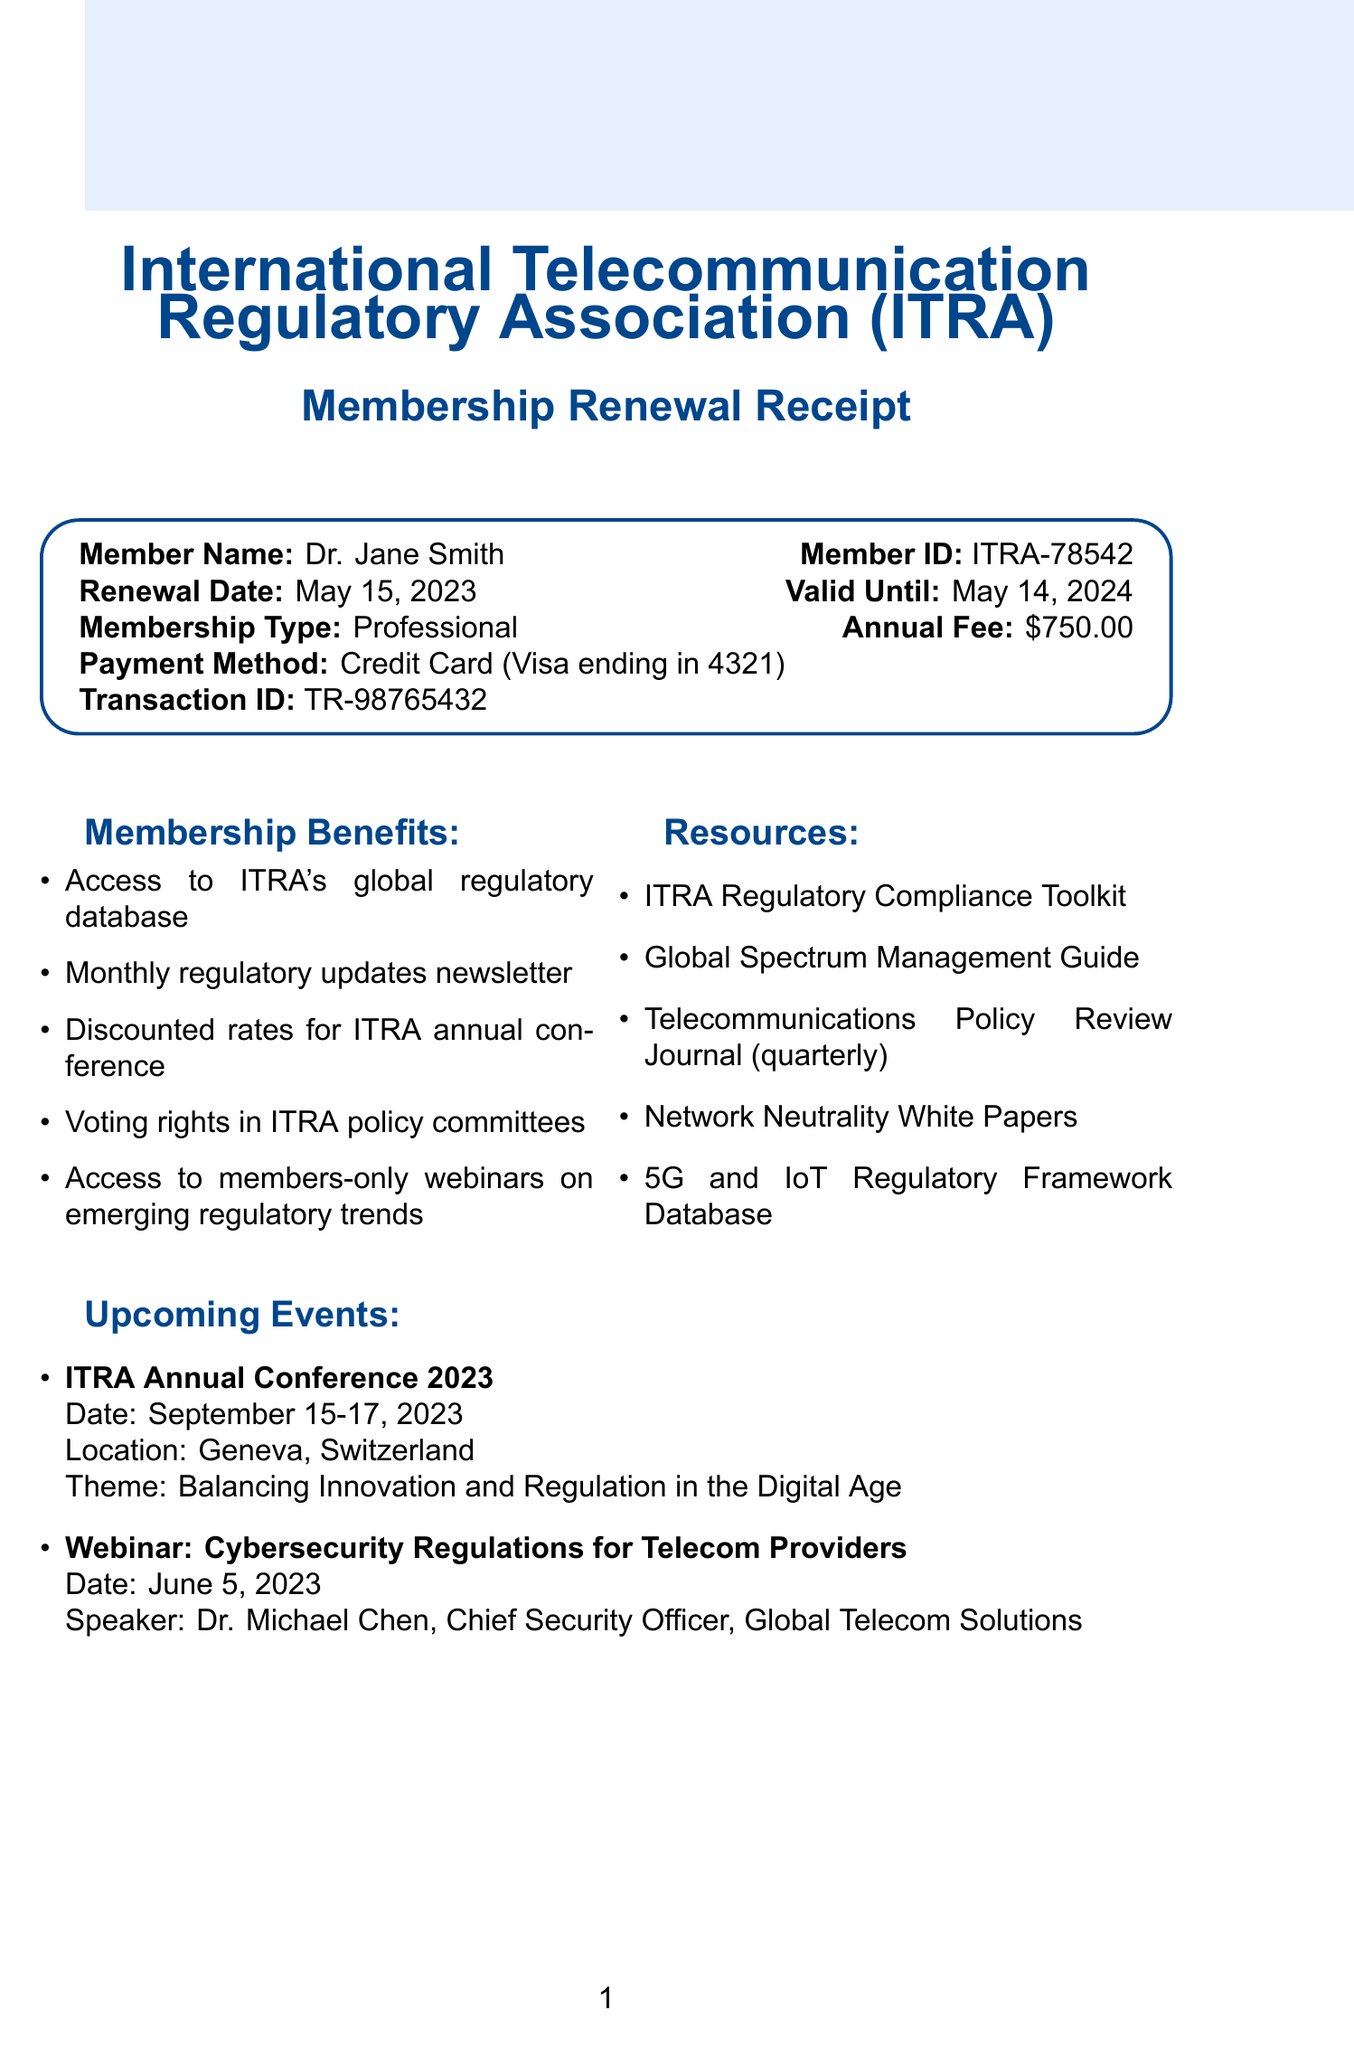What is the name of the association? The name of the association is explicitly stated in the document as the International Telecommunication Regulatory Association.
Answer: International Telecommunication Regulatory Association (ITRA) What is the member ID of Dr. Jane Smith? The member ID is a specific identifier for the individual, provided clearly in the receipt.
Answer: ITRA-78542 When does the membership expire? The document specifies the validity period of the membership, indicating the end date.
Answer: May 14, 2024 What is the annual fee for the professional membership? The annual fee for membership is listed directly in the document.
Answer: $750.00 What is one of the resources available to members? The document lists several resources available to members, indicating they can access these as part of their membership.
Answer: ITRA Regulatory Compliance Toolkit What is the date of the upcoming ITRA Annual Conference? The date for the conference is presented as part of the upcoming events section in the document.
Answer: September 15-17, 2023 How many benefits are listed in the membership receipt? The document outlines a specific number of benefits in a bullet-point format.
Answer: Five What type of payment method was used for the renewal? The receipt provides details about the payment method used to complete the transaction.
Answer: Credit Card (Visa ending in 4321) What is the tax deductible amount stated in the document? The document mentions a specific amount that is tax deductible for accounting purposes.
Answer: $600.00 What is the theme of the ITRA Annual Conference 2023? The theme is clearly stated in the details about the upcoming events in the document.
Answer: Balancing Innovation and Regulation in the Digital Age 